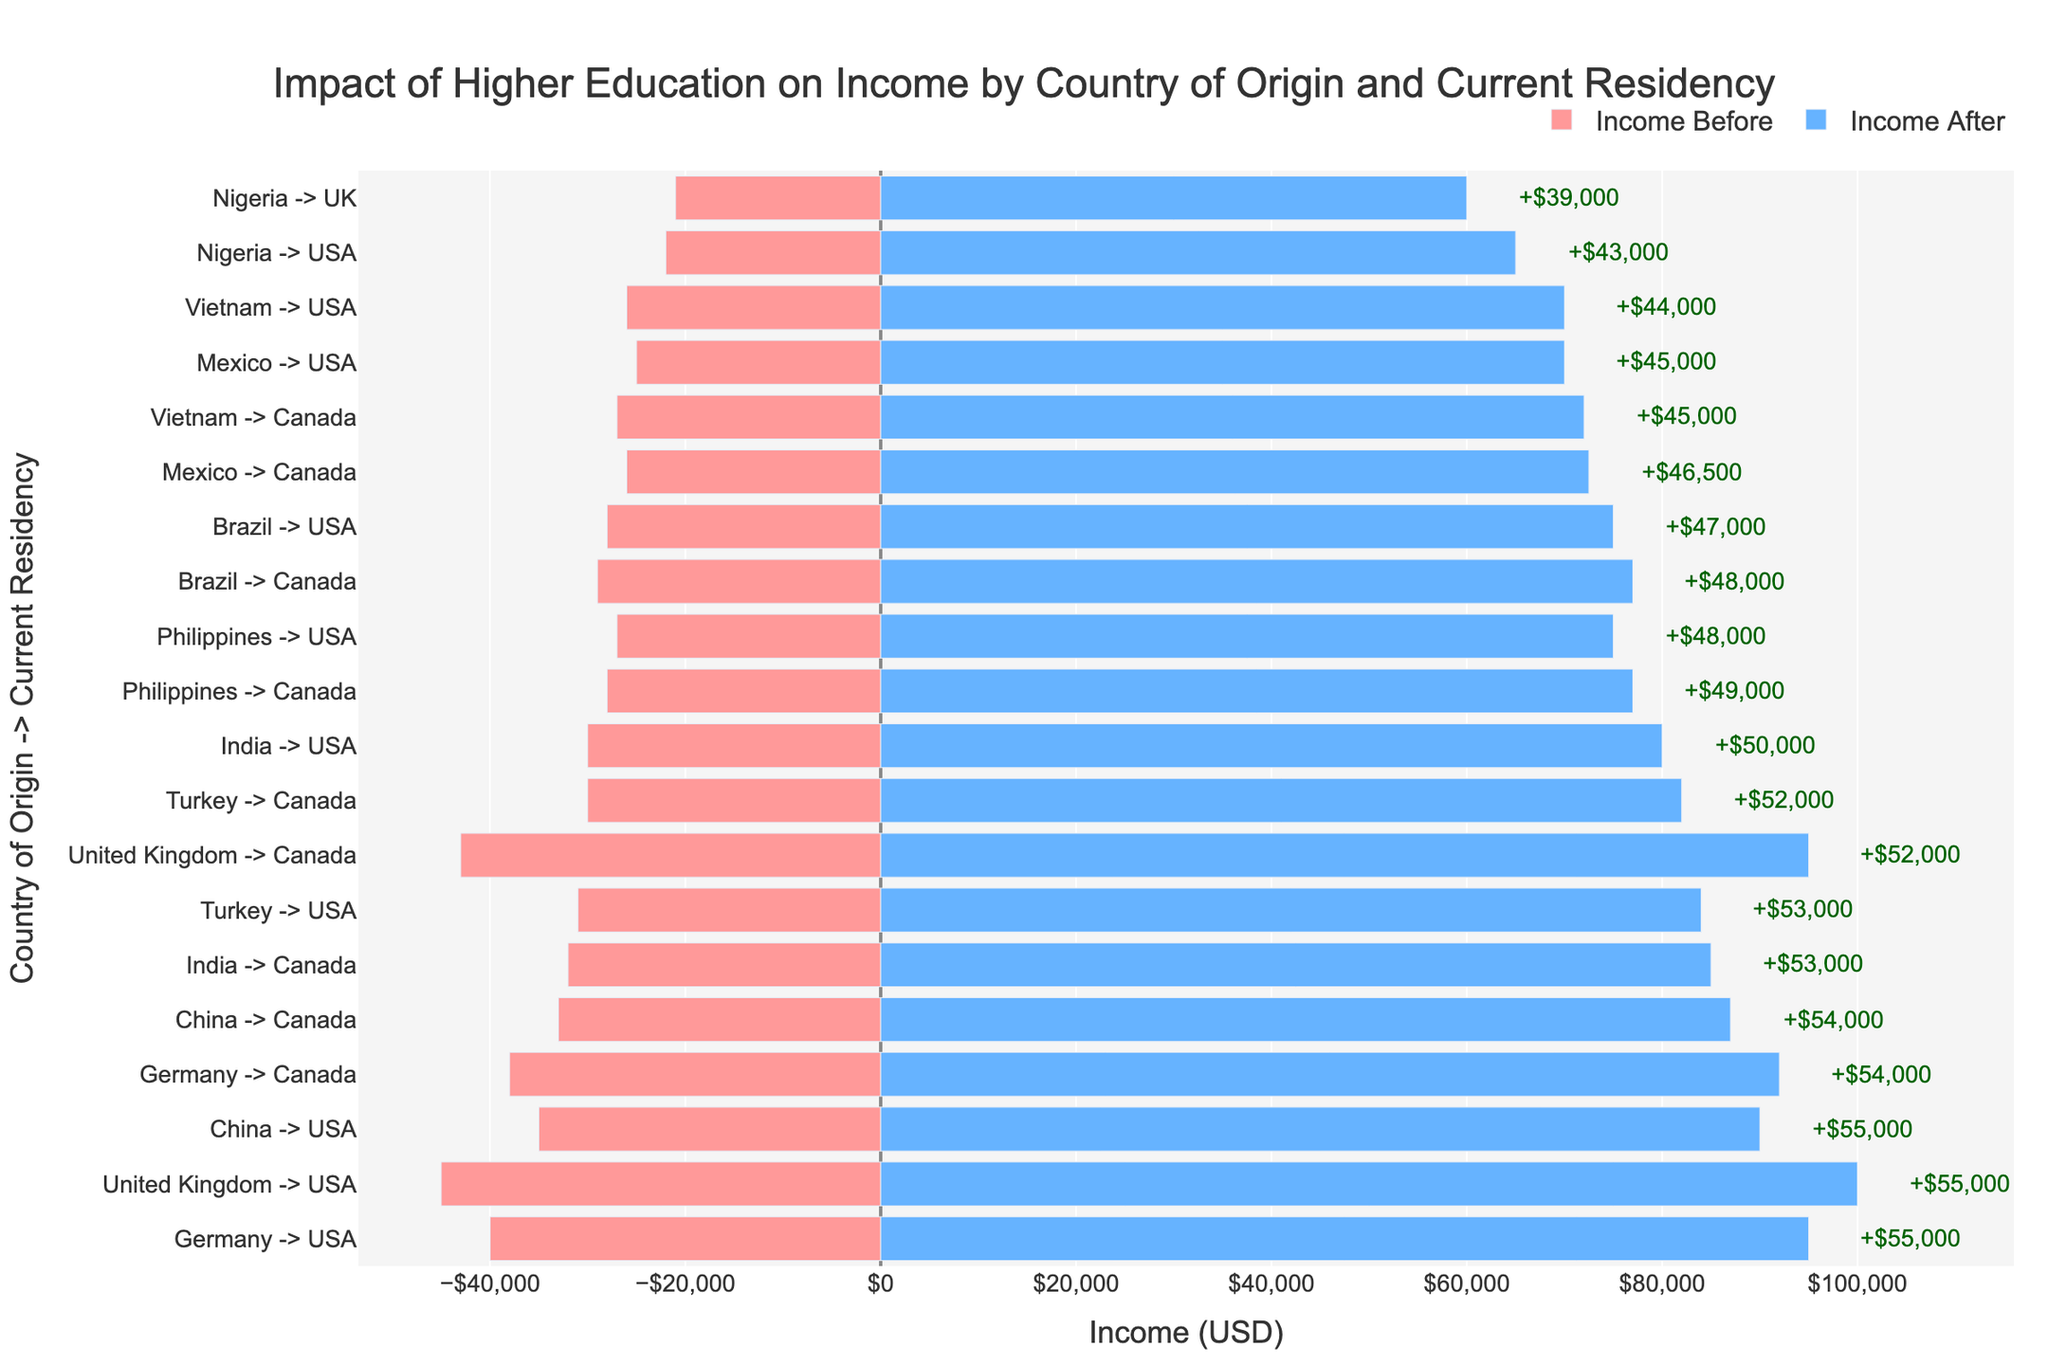What's the highest income difference between 'Before' and 'After' higher education? To find this, look at the annotations on the figure that show income differences. The highest annotated difference is for the category 'United Kingdom -> USA' with "+$55,000".
Answer: $55,000 Which country-residency pair has the lowest income before higher education? Check the bar chart for the shortest bar on the negative side. The shortest bar in red represents 'Nigeria -> UK' with an income before higher education at $21,000.
Answer: Nigeria -> UK In which country-residency pair is the highest income after higher education found? Find the tallest bar on the positive side. The tallest bar in blue represents 'United Kingdom -> USA' with $100,000 income after higher education.
Answer: United Kingdom -> USA What is the income difference for 'China -> USA'? Look at the annotations for 'China -> USA'. The annotation indicates an income difference of "+$55,000".
Answer: $55,000 Compare the income after higher education for 'India -> USA' and 'India -> Canada'. Which is higher and by how much? Check the respective bars in blue for 'India -> USA' and 'India -> Canada'. 'India -> USA' has $80,000 and 'India -> Canada' has $85,000. The difference is $5,000.
Answer: India -> Canada by $5,000 How does the income difference for 'Brazil -> USA' compare to 'Mexico -> USA'? Find the annotations for both pairs. 'Brazil -> USA' has an income difference of $47,000 and 'Mexico -> USA' has $45,000, so 'Brazil -> USA' has a $2,000 greater difference.
Answer: Brazil -> USA by $2,000 What is the average income before higher education across all country-residency pairs? Sum all income before higher education then divide by the number of data points: (30000 + 32000 + 25000 + 26000 + 27000 + 28000 + 35000 + 33000 + 22000 + 21000 + 40000 + 38000 + 45000 + 43000 + 28000 + 29000 + 26000 + 27000 + 31000 + 30000) / 20 = 30,300
Answer: $30,300 Which country-residency pair shows the smallest increase in income after higher education? Look for the smallest positive difference among the annotations. 'Nigeria -> UK' shows the smallest increase of $39,000.
Answer: Nigeria -> UK What is the difference in income increase between 'Philippines -> USA' and 'Philippines -> Canada'? The income difference for 'Philippines -> USA' is 75,000 - 27,000 = 48,000 and for 'Philippines -> Canada' is 77,000 - 28,000 = 49,000. The difference in income increase is 49,000 - 48,000 = $1,000.
Answer: $1,000 